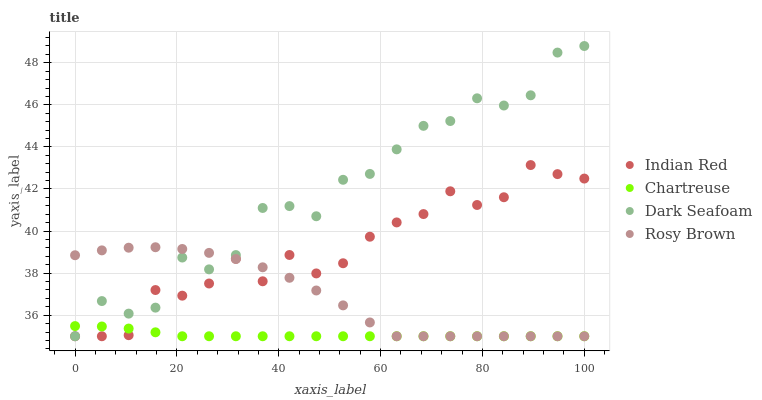Does Chartreuse have the minimum area under the curve?
Answer yes or no. Yes. Does Dark Seafoam have the maximum area under the curve?
Answer yes or no. Yes. Does Rosy Brown have the minimum area under the curve?
Answer yes or no. No. Does Rosy Brown have the maximum area under the curve?
Answer yes or no. No. Is Chartreuse the smoothest?
Answer yes or no. Yes. Is Dark Seafoam the roughest?
Answer yes or no. Yes. Is Rosy Brown the smoothest?
Answer yes or no. No. Is Rosy Brown the roughest?
Answer yes or no. No. Does Chartreuse have the lowest value?
Answer yes or no. Yes. Does Dark Seafoam have the highest value?
Answer yes or no. Yes. Does Rosy Brown have the highest value?
Answer yes or no. No. Does Indian Red intersect Chartreuse?
Answer yes or no. Yes. Is Indian Red less than Chartreuse?
Answer yes or no. No. Is Indian Red greater than Chartreuse?
Answer yes or no. No. 